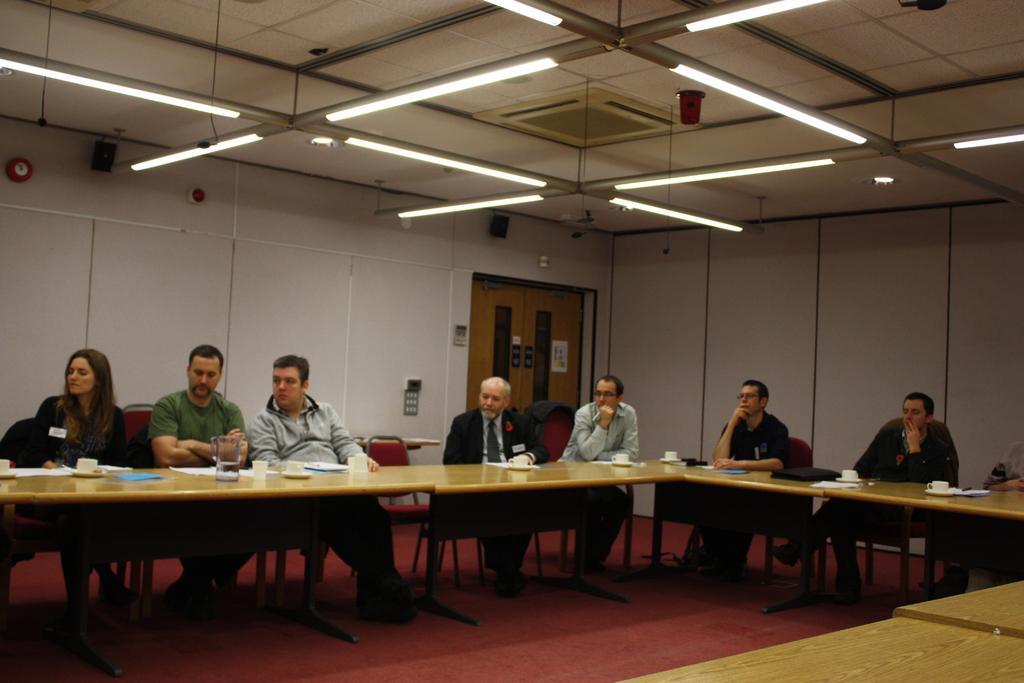Can you describe this image briefly? In this picture there are a group of people sitting and they have a table in front of them with coffee cup water jar and into right we find the door 